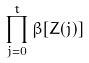<formula> <loc_0><loc_0><loc_500><loc_500>\prod _ { j = 0 } ^ { t } \beta [ Z ( j ) ]</formula> 